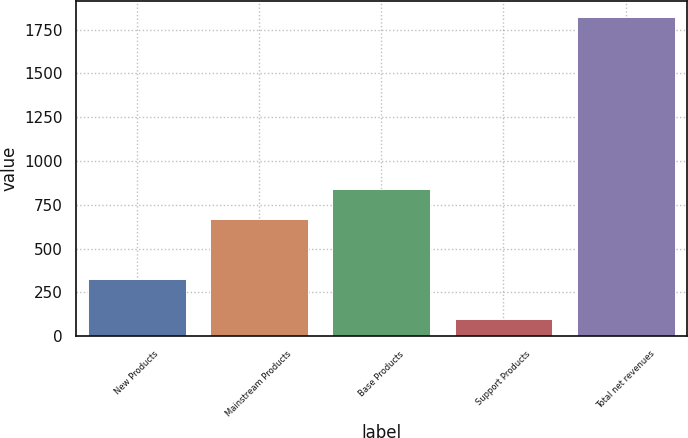Convert chart. <chart><loc_0><loc_0><loc_500><loc_500><bar_chart><fcel>New Products<fcel>Mainstream Products<fcel>Base Products<fcel>Support Products<fcel>Total net revenues<nl><fcel>325.9<fcel>666.1<fcel>838.82<fcel>98<fcel>1825.2<nl></chart> 